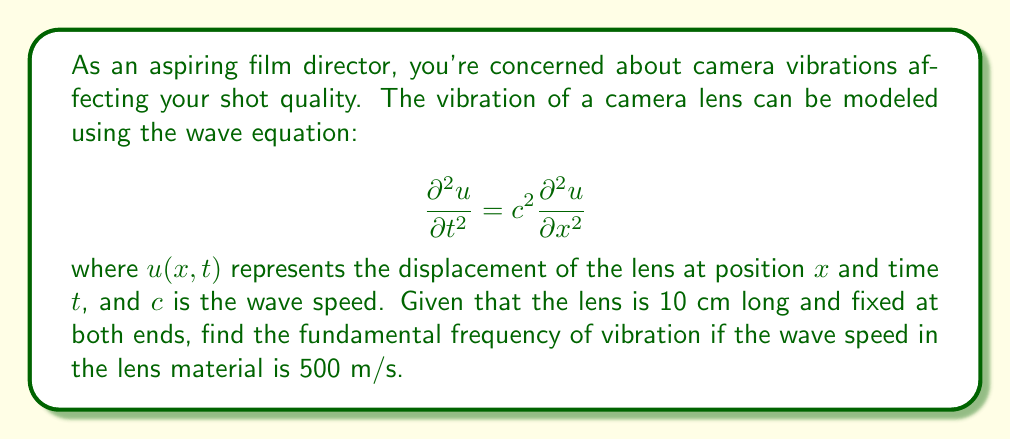Help me with this question. To solve this problem, we'll follow these steps:

1) For a string (or in this case, a lens) fixed at both ends, the general solution to the wave equation is:

   $$u(x,t) = \sum_{n=1}^{\infty} A_n \sin(\frac{n\pi x}{L}) \cos(\frac{n\pi c t}{L})$$

   where $L$ is the length of the string/lens.

2) The fundamental frequency corresponds to $n=1$. The frequency $f$ is related to the angular frequency $\omega$ by:

   $$f = \frac{\omega}{2\pi}$$

3) From the cosine term in the general solution, we can see that:

   $$\omega = \frac{\pi c}{L}$$

4) Substituting this into the frequency equation:

   $$f = \frac{c}{2L}$$

5) We're given:
   - $c = 500$ m/s
   - $L = 10$ cm = 0.1 m

6) Plugging these values into our equation:

   $$f = \frac{500}{2(0.1)} = 2500 \text{ Hz}$$

Thus, the fundamental frequency of vibration is 2500 Hz.
Answer: 2500 Hz 